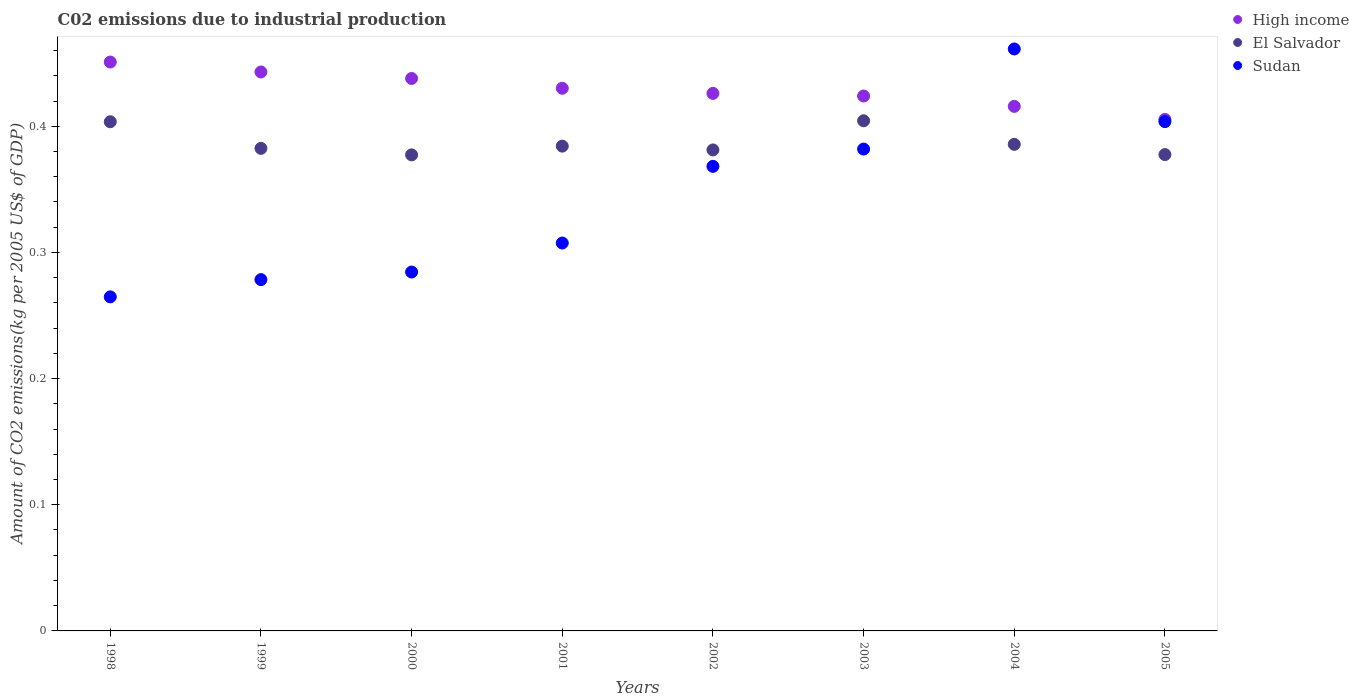Is the number of dotlines equal to the number of legend labels?
Provide a short and direct response. Yes. What is the amount of CO2 emitted due to industrial production in Sudan in 1999?
Give a very brief answer. 0.28. Across all years, what is the maximum amount of CO2 emitted due to industrial production in Sudan?
Offer a terse response. 0.46. Across all years, what is the minimum amount of CO2 emitted due to industrial production in Sudan?
Your answer should be compact. 0.26. What is the total amount of CO2 emitted due to industrial production in El Salvador in the graph?
Keep it short and to the point. 3.1. What is the difference between the amount of CO2 emitted due to industrial production in Sudan in 1998 and that in 2004?
Your answer should be very brief. -0.2. What is the difference between the amount of CO2 emitted due to industrial production in Sudan in 2004 and the amount of CO2 emitted due to industrial production in El Salvador in 2002?
Make the answer very short. 0.08. What is the average amount of CO2 emitted due to industrial production in High income per year?
Your response must be concise. 0.43. In the year 1998, what is the difference between the amount of CO2 emitted due to industrial production in El Salvador and amount of CO2 emitted due to industrial production in High income?
Your response must be concise. -0.05. In how many years, is the amount of CO2 emitted due to industrial production in High income greater than 0.1 kg?
Give a very brief answer. 8. What is the ratio of the amount of CO2 emitted due to industrial production in Sudan in 2003 to that in 2004?
Offer a terse response. 0.83. Is the difference between the amount of CO2 emitted due to industrial production in El Salvador in 2002 and 2003 greater than the difference between the amount of CO2 emitted due to industrial production in High income in 2002 and 2003?
Offer a terse response. No. What is the difference between the highest and the second highest amount of CO2 emitted due to industrial production in Sudan?
Your response must be concise. 0.06. What is the difference between the highest and the lowest amount of CO2 emitted due to industrial production in Sudan?
Your answer should be compact. 0.2. Is the sum of the amount of CO2 emitted due to industrial production in High income in 1998 and 2002 greater than the maximum amount of CO2 emitted due to industrial production in Sudan across all years?
Your response must be concise. Yes. Is it the case that in every year, the sum of the amount of CO2 emitted due to industrial production in High income and amount of CO2 emitted due to industrial production in Sudan  is greater than the amount of CO2 emitted due to industrial production in El Salvador?
Your answer should be very brief. Yes. Is the amount of CO2 emitted due to industrial production in El Salvador strictly greater than the amount of CO2 emitted due to industrial production in Sudan over the years?
Keep it short and to the point. No. Is the amount of CO2 emitted due to industrial production in High income strictly less than the amount of CO2 emitted due to industrial production in Sudan over the years?
Your answer should be compact. No. How many dotlines are there?
Provide a succinct answer. 3. Are the values on the major ticks of Y-axis written in scientific E-notation?
Give a very brief answer. No. Where does the legend appear in the graph?
Offer a terse response. Top right. How many legend labels are there?
Your answer should be compact. 3. What is the title of the graph?
Provide a succinct answer. C02 emissions due to industrial production. What is the label or title of the Y-axis?
Your answer should be very brief. Amount of CO2 emissions(kg per 2005 US$ of GDP). What is the Amount of CO2 emissions(kg per 2005 US$ of GDP) in High income in 1998?
Provide a succinct answer. 0.45. What is the Amount of CO2 emissions(kg per 2005 US$ of GDP) in El Salvador in 1998?
Provide a succinct answer. 0.4. What is the Amount of CO2 emissions(kg per 2005 US$ of GDP) in Sudan in 1998?
Ensure brevity in your answer.  0.26. What is the Amount of CO2 emissions(kg per 2005 US$ of GDP) in High income in 1999?
Offer a terse response. 0.44. What is the Amount of CO2 emissions(kg per 2005 US$ of GDP) in El Salvador in 1999?
Your answer should be compact. 0.38. What is the Amount of CO2 emissions(kg per 2005 US$ of GDP) of Sudan in 1999?
Give a very brief answer. 0.28. What is the Amount of CO2 emissions(kg per 2005 US$ of GDP) in High income in 2000?
Offer a terse response. 0.44. What is the Amount of CO2 emissions(kg per 2005 US$ of GDP) of El Salvador in 2000?
Offer a very short reply. 0.38. What is the Amount of CO2 emissions(kg per 2005 US$ of GDP) of Sudan in 2000?
Provide a succinct answer. 0.28. What is the Amount of CO2 emissions(kg per 2005 US$ of GDP) in High income in 2001?
Offer a terse response. 0.43. What is the Amount of CO2 emissions(kg per 2005 US$ of GDP) of El Salvador in 2001?
Provide a short and direct response. 0.38. What is the Amount of CO2 emissions(kg per 2005 US$ of GDP) in Sudan in 2001?
Give a very brief answer. 0.31. What is the Amount of CO2 emissions(kg per 2005 US$ of GDP) of High income in 2002?
Your response must be concise. 0.43. What is the Amount of CO2 emissions(kg per 2005 US$ of GDP) in El Salvador in 2002?
Make the answer very short. 0.38. What is the Amount of CO2 emissions(kg per 2005 US$ of GDP) of Sudan in 2002?
Provide a succinct answer. 0.37. What is the Amount of CO2 emissions(kg per 2005 US$ of GDP) in High income in 2003?
Make the answer very short. 0.42. What is the Amount of CO2 emissions(kg per 2005 US$ of GDP) in El Salvador in 2003?
Your response must be concise. 0.4. What is the Amount of CO2 emissions(kg per 2005 US$ of GDP) of Sudan in 2003?
Ensure brevity in your answer.  0.38. What is the Amount of CO2 emissions(kg per 2005 US$ of GDP) of High income in 2004?
Provide a succinct answer. 0.42. What is the Amount of CO2 emissions(kg per 2005 US$ of GDP) of El Salvador in 2004?
Provide a short and direct response. 0.39. What is the Amount of CO2 emissions(kg per 2005 US$ of GDP) of Sudan in 2004?
Provide a succinct answer. 0.46. What is the Amount of CO2 emissions(kg per 2005 US$ of GDP) of High income in 2005?
Your answer should be very brief. 0.41. What is the Amount of CO2 emissions(kg per 2005 US$ of GDP) in El Salvador in 2005?
Keep it short and to the point. 0.38. What is the Amount of CO2 emissions(kg per 2005 US$ of GDP) in Sudan in 2005?
Make the answer very short. 0.4. Across all years, what is the maximum Amount of CO2 emissions(kg per 2005 US$ of GDP) of High income?
Make the answer very short. 0.45. Across all years, what is the maximum Amount of CO2 emissions(kg per 2005 US$ of GDP) of El Salvador?
Offer a terse response. 0.4. Across all years, what is the maximum Amount of CO2 emissions(kg per 2005 US$ of GDP) in Sudan?
Provide a succinct answer. 0.46. Across all years, what is the minimum Amount of CO2 emissions(kg per 2005 US$ of GDP) in High income?
Ensure brevity in your answer.  0.41. Across all years, what is the minimum Amount of CO2 emissions(kg per 2005 US$ of GDP) of El Salvador?
Give a very brief answer. 0.38. Across all years, what is the minimum Amount of CO2 emissions(kg per 2005 US$ of GDP) in Sudan?
Give a very brief answer. 0.26. What is the total Amount of CO2 emissions(kg per 2005 US$ of GDP) of High income in the graph?
Your answer should be compact. 3.43. What is the total Amount of CO2 emissions(kg per 2005 US$ of GDP) of El Salvador in the graph?
Ensure brevity in your answer.  3.1. What is the total Amount of CO2 emissions(kg per 2005 US$ of GDP) of Sudan in the graph?
Provide a succinct answer. 2.75. What is the difference between the Amount of CO2 emissions(kg per 2005 US$ of GDP) of High income in 1998 and that in 1999?
Make the answer very short. 0.01. What is the difference between the Amount of CO2 emissions(kg per 2005 US$ of GDP) of El Salvador in 1998 and that in 1999?
Make the answer very short. 0.02. What is the difference between the Amount of CO2 emissions(kg per 2005 US$ of GDP) in Sudan in 1998 and that in 1999?
Offer a terse response. -0.01. What is the difference between the Amount of CO2 emissions(kg per 2005 US$ of GDP) in High income in 1998 and that in 2000?
Your response must be concise. 0.01. What is the difference between the Amount of CO2 emissions(kg per 2005 US$ of GDP) of El Salvador in 1998 and that in 2000?
Keep it short and to the point. 0.03. What is the difference between the Amount of CO2 emissions(kg per 2005 US$ of GDP) of Sudan in 1998 and that in 2000?
Offer a terse response. -0.02. What is the difference between the Amount of CO2 emissions(kg per 2005 US$ of GDP) of High income in 1998 and that in 2001?
Keep it short and to the point. 0.02. What is the difference between the Amount of CO2 emissions(kg per 2005 US$ of GDP) in El Salvador in 1998 and that in 2001?
Provide a succinct answer. 0.02. What is the difference between the Amount of CO2 emissions(kg per 2005 US$ of GDP) of Sudan in 1998 and that in 2001?
Give a very brief answer. -0.04. What is the difference between the Amount of CO2 emissions(kg per 2005 US$ of GDP) of High income in 1998 and that in 2002?
Make the answer very short. 0.02. What is the difference between the Amount of CO2 emissions(kg per 2005 US$ of GDP) in El Salvador in 1998 and that in 2002?
Your answer should be very brief. 0.02. What is the difference between the Amount of CO2 emissions(kg per 2005 US$ of GDP) in Sudan in 1998 and that in 2002?
Your response must be concise. -0.1. What is the difference between the Amount of CO2 emissions(kg per 2005 US$ of GDP) of High income in 1998 and that in 2003?
Provide a short and direct response. 0.03. What is the difference between the Amount of CO2 emissions(kg per 2005 US$ of GDP) in El Salvador in 1998 and that in 2003?
Keep it short and to the point. -0. What is the difference between the Amount of CO2 emissions(kg per 2005 US$ of GDP) in Sudan in 1998 and that in 2003?
Keep it short and to the point. -0.12. What is the difference between the Amount of CO2 emissions(kg per 2005 US$ of GDP) of High income in 1998 and that in 2004?
Provide a short and direct response. 0.04. What is the difference between the Amount of CO2 emissions(kg per 2005 US$ of GDP) of El Salvador in 1998 and that in 2004?
Offer a very short reply. 0.02. What is the difference between the Amount of CO2 emissions(kg per 2005 US$ of GDP) in Sudan in 1998 and that in 2004?
Provide a succinct answer. -0.2. What is the difference between the Amount of CO2 emissions(kg per 2005 US$ of GDP) of High income in 1998 and that in 2005?
Provide a short and direct response. 0.05. What is the difference between the Amount of CO2 emissions(kg per 2005 US$ of GDP) in El Salvador in 1998 and that in 2005?
Offer a very short reply. 0.03. What is the difference between the Amount of CO2 emissions(kg per 2005 US$ of GDP) in Sudan in 1998 and that in 2005?
Keep it short and to the point. -0.14. What is the difference between the Amount of CO2 emissions(kg per 2005 US$ of GDP) in High income in 1999 and that in 2000?
Ensure brevity in your answer.  0.01. What is the difference between the Amount of CO2 emissions(kg per 2005 US$ of GDP) in El Salvador in 1999 and that in 2000?
Make the answer very short. 0.01. What is the difference between the Amount of CO2 emissions(kg per 2005 US$ of GDP) of Sudan in 1999 and that in 2000?
Offer a very short reply. -0.01. What is the difference between the Amount of CO2 emissions(kg per 2005 US$ of GDP) of High income in 1999 and that in 2001?
Your response must be concise. 0.01. What is the difference between the Amount of CO2 emissions(kg per 2005 US$ of GDP) of El Salvador in 1999 and that in 2001?
Give a very brief answer. -0. What is the difference between the Amount of CO2 emissions(kg per 2005 US$ of GDP) in Sudan in 1999 and that in 2001?
Your answer should be compact. -0.03. What is the difference between the Amount of CO2 emissions(kg per 2005 US$ of GDP) of High income in 1999 and that in 2002?
Ensure brevity in your answer.  0.02. What is the difference between the Amount of CO2 emissions(kg per 2005 US$ of GDP) of El Salvador in 1999 and that in 2002?
Your response must be concise. 0. What is the difference between the Amount of CO2 emissions(kg per 2005 US$ of GDP) in Sudan in 1999 and that in 2002?
Make the answer very short. -0.09. What is the difference between the Amount of CO2 emissions(kg per 2005 US$ of GDP) of High income in 1999 and that in 2003?
Offer a very short reply. 0.02. What is the difference between the Amount of CO2 emissions(kg per 2005 US$ of GDP) in El Salvador in 1999 and that in 2003?
Make the answer very short. -0.02. What is the difference between the Amount of CO2 emissions(kg per 2005 US$ of GDP) of Sudan in 1999 and that in 2003?
Provide a succinct answer. -0.1. What is the difference between the Amount of CO2 emissions(kg per 2005 US$ of GDP) in High income in 1999 and that in 2004?
Ensure brevity in your answer.  0.03. What is the difference between the Amount of CO2 emissions(kg per 2005 US$ of GDP) in El Salvador in 1999 and that in 2004?
Your answer should be very brief. -0. What is the difference between the Amount of CO2 emissions(kg per 2005 US$ of GDP) of Sudan in 1999 and that in 2004?
Keep it short and to the point. -0.18. What is the difference between the Amount of CO2 emissions(kg per 2005 US$ of GDP) in High income in 1999 and that in 2005?
Keep it short and to the point. 0.04. What is the difference between the Amount of CO2 emissions(kg per 2005 US$ of GDP) of El Salvador in 1999 and that in 2005?
Provide a short and direct response. 0. What is the difference between the Amount of CO2 emissions(kg per 2005 US$ of GDP) in Sudan in 1999 and that in 2005?
Provide a succinct answer. -0.13. What is the difference between the Amount of CO2 emissions(kg per 2005 US$ of GDP) in High income in 2000 and that in 2001?
Provide a succinct answer. 0.01. What is the difference between the Amount of CO2 emissions(kg per 2005 US$ of GDP) in El Salvador in 2000 and that in 2001?
Offer a very short reply. -0.01. What is the difference between the Amount of CO2 emissions(kg per 2005 US$ of GDP) of Sudan in 2000 and that in 2001?
Give a very brief answer. -0.02. What is the difference between the Amount of CO2 emissions(kg per 2005 US$ of GDP) in High income in 2000 and that in 2002?
Your response must be concise. 0.01. What is the difference between the Amount of CO2 emissions(kg per 2005 US$ of GDP) in El Salvador in 2000 and that in 2002?
Ensure brevity in your answer.  -0. What is the difference between the Amount of CO2 emissions(kg per 2005 US$ of GDP) of Sudan in 2000 and that in 2002?
Give a very brief answer. -0.08. What is the difference between the Amount of CO2 emissions(kg per 2005 US$ of GDP) of High income in 2000 and that in 2003?
Keep it short and to the point. 0.01. What is the difference between the Amount of CO2 emissions(kg per 2005 US$ of GDP) in El Salvador in 2000 and that in 2003?
Give a very brief answer. -0.03. What is the difference between the Amount of CO2 emissions(kg per 2005 US$ of GDP) in Sudan in 2000 and that in 2003?
Keep it short and to the point. -0.1. What is the difference between the Amount of CO2 emissions(kg per 2005 US$ of GDP) of High income in 2000 and that in 2004?
Ensure brevity in your answer.  0.02. What is the difference between the Amount of CO2 emissions(kg per 2005 US$ of GDP) of El Salvador in 2000 and that in 2004?
Provide a short and direct response. -0.01. What is the difference between the Amount of CO2 emissions(kg per 2005 US$ of GDP) in Sudan in 2000 and that in 2004?
Your response must be concise. -0.18. What is the difference between the Amount of CO2 emissions(kg per 2005 US$ of GDP) in High income in 2000 and that in 2005?
Your answer should be compact. 0.03. What is the difference between the Amount of CO2 emissions(kg per 2005 US$ of GDP) in El Salvador in 2000 and that in 2005?
Ensure brevity in your answer.  -0. What is the difference between the Amount of CO2 emissions(kg per 2005 US$ of GDP) of Sudan in 2000 and that in 2005?
Ensure brevity in your answer.  -0.12. What is the difference between the Amount of CO2 emissions(kg per 2005 US$ of GDP) of High income in 2001 and that in 2002?
Give a very brief answer. 0. What is the difference between the Amount of CO2 emissions(kg per 2005 US$ of GDP) of El Salvador in 2001 and that in 2002?
Make the answer very short. 0. What is the difference between the Amount of CO2 emissions(kg per 2005 US$ of GDP) in Sudan in 2001 and that in 2002?
Offer a terse response. -0.06. What is the difference between the Amount of CO2 emissions(kg per 2005 US$ of GDP) of High income in 2001 and that in 2003?
Your response must be concise. 0.01. What is the difference between the Amount of CO2 emissions(kg per 2005 US$ of GDP) in El Salvador in 2001 and that in 2003?
Make the answer very short. -0.02. What is the difference between the Amount of CO2 emissions(kg per 2005 US$ of GDP) of Sudan in 2001 and that in 2003?
Offer a very short reply. -0.07. What is the difference between the Amount of CO2 emissions(kg per 2005 US$ of GDP) in High income in 2001 and that in 2004?
Provide a succinct answer. 0.01. What is the difference between the Amount of CO2 emissions(kg per 2005 US$ of GDP) of El Salvador in 2001 and that in 2004?
Provide a succinct answer. -0. What is the difference between the Amount of CO2 emissions(kg per 2005 US$ of GDP) in Sudan in 2001 and that in 2004?
Offer a terse response. -0.15. What is the difference between the Amount of CO2 emissions(kg per 2005 US$ of GDP) of High income in 2001 and that in 2005?
Your answer should be compact. 0.02. What is the difference between the Amount of CO2 emissions(kg per 2005 US$ of GDP) in El Salvador in 2001 and that in 2005?
Give a very brief answer. 0.01. What is the difference between the Amount of CO2 emissions(kg per 2005 US$ of GDP) of Sudan in 2001 and that in 2005?
Ensure brevity in your answer.  -0.1. What is the difference between the Amount of CO2 emissions(kg per 2005 US$ of GDP) in High income in 2002 and that in 2003?
Ensure brevity in your answer.  0. What is the difference between the Amount of CO2 emissions(kg per 2005 US$ of GDP) in El Salvador in 2002 and that in 2003?
Your response must be concise. -0.02. What is the difference between the Amount of CO2 emissions(kg per 2005 US$ of GDP) in Sudan in 2002 and that in 2003?
Provide a short and direct response. -0.01. What is the difference between the Amount of CO2 emissions(kg per 2005 US$ of GDP) of High income in 2002 and that in 2004?
Make the answer very short. 0.01. What is the difference between the Amount of CO2 emissions(kg per 2005 US$ of GDP) of El Salvador in 2002 and that in 2004?
Your answer should be compact. -0. What is the difference between the Amount of CO2 emissions(kg per 2005 US$ of GDP) of Sudan in 2002 and that in 2004?
Your answer should be compact. -0.09. What is the difference between the Amount of CO2 emissions(kg per 2005 US$ of GDP) of High income in 2002 and that in 2005?
Give a very brief answer. 0.02. What is the difference between the Amount of CO2 emissions(kg per 2005 US$ of GDP) of El Salvador in 2002 and that in 2005?
Your answer should be compact. 0. What is the difference between the Amount of CO2 emissions(kg per 2005 US$ of GDP) of Sudan in 2002 and that in 2005?
Your answer should be compact. -0.04. What is the difference between the Amount of CO2 emissions(kg per 2005 US$ of GDP) of High income in 2003 and that in 2004?
Your response must be concise. 0.01. What is the difference between the Amount of CO2 emissions(kg per 2005 US$ of GDP) of El Salvador in 2003 and that in 2004?
Provide a short and direct response. 0.02. What is the difference between the Amount of CO2 emissions(kg per 2005 US$ of GDP) in Sudan in 2003 and that in 2004?
Offer a very short reply. -0.08. What is the difference between the Amount of CO2 emissions(kg per 2005 US$ of GDP) in High income in 2003 and that in 2005?
Your answer should be compact. 0.02. What is the difference between the Amount of CO2 emissions(kg per 2005 US$ of GDP) of El Salvador in 2003 and that in 2005?
Provide a succinct answer. 0.03. What is the difference between the Amount of CO2 emissions(kg per 2005 US$ of GDP) of Sudan in 2003 and that in 2005?
Your response must be concise. -0.02. What is the difference between the Amount of CO2 emissions(kg per 2005 US$ of GDP) in High income in 2004 and that in 2005?
Keep it short and to the point. 0.01. What is the difference between the Amount of CO2 emissions(kg per 2005 US$ of GDP) in El Salvador in 2004 and that in 2005?
Offer a very short reply. 0.01. What is the difference between the Amount of CO2 emissions(kg per 2005 US$ of GDP) of Sudan in 2004 and that in 2005?
Your answer should be compact. 0.06. What is the difference between the Amount of CO2 emissions(kg per 2005 US$ of GDP) in High income in 1998 and the Amount of CO2 emissions(kg per 2005 US$ of GDP) in El Salvador in 1999?
Offer a terse response. 0.07. What is the difference between the Amount of CO2 emissions(kg per 2005 US$ of GDP) in High income in 1998 and the Amount of CO2 emissions(kg per 2005 US$ of GDP) in Sudan in 1999?
Offer a very short reply. 0.17. What is the difference between the Amount of CO2 emissions(kg per 2005 US$ of GDP) of El Salvador in 1998 and the Amount of CO2 emissions(kg per 2005 US$ of GDP) of Sudan in 1999?
Keep it short and to the point. 0.13. What is the difference between the Amount of CO2 emissions(kg per 2005 US$ of GDP) in High income in 1998 and the Amount of CO2 emissions(kg per 2005 US$ of GDP) in El Salvador in 2000?
Make the answer very short. 0.07. What is the difference between the Amount of CO2 emissions(kg per 2005 US$ of GDP) in High income in 1998 and the Amount of CO2 emissions(kg per 2005 US$ of GDP) in Sudan in 2000?
Keep it short and to the point. 0.17. What is the difference between the Amount of CO2 emissions(kg per 2005 US$ of GDP) in El Salvador in 1998 and the Amount of CO2 emissions(kg per 2005 US$ of GDP) in Sudan in 2000?
Make the answer very short. 0.12. What is the difference between the Amount of CO2 emissions(kg per 2005 US$ of GDP) of High income in 1998 and the Amount of CO2 emissions(kg per 2005 US$ of GDP) of El Salvador in 2001?
Make the answer very short. 0.07. What is the difference between the Amount of CO2 emissions(kg per 2005 US$ of GDP) of High income in 1998 and the Amount of CO2 emissions(kg per 2005 US$ of GDP) of Sudan in 2001?
Ensure brevity in your answer.  0.14. What is the difference between the Amount of CO2 emissions(kg per 2005 US$ of GDP) in El Salvador in 1998 and the Amount of CO2 emissions(kg per 2005 US$ of GDP) in Sudan in 2001?
Offer a terse response. 0.1. What is the difference between the Amount of CO2 emissions(kg per 2005 US$ of GDP) in High income in 1998 and the Amount of CO2 emissions(kg per 2005 US$ of GDP) in El Salvador in 2002?
Ensure brevity in your answer.  0.07. What is the difference between the Amount of CO2 emissions(kg per 2005 US$ of GDP) of High income in 1998 and the Amount of CO2 emissions(kg per 2005 US$ of GDP) of Sudan in 2002?
Provide a short and direct response. 0.08. What is the difference between the Amount of CO2 emissions(kg per 2005 US$ of GDP) of El Salvador in 1998 and the Amount of CO2 emissions(kg per 2005 US$ of GDP) of Sudan in 2002?
Provide a short and direct response. 0.04. What is the difference between the Amount of CO2 emissions(kg per 2005 US$ of GDP) in High income in 1998 and the Amount of CO2 emissions(kg per 2005 US$ of GDP) in El Salvador in 2003?
Give a very brief answer. 0.05. What is the difference between the Amount of CO2 emissions(kg per 2005 US$ of GDP) in High income in 1998 and the Amount of CO2 emissions(kg per 2005 US$ of GDP) in Sudan in 2003?
Your answer should be compact. 0.07. What is the difference between the Amount of CO2 emissions(kg per 2005 US$ of GDP) in El Salvador in 1998 and the Amount of CO2 emissions(kg per 2005 US$ of GDP) in Sudan in 2003?
Your response must be concise. 0.02. What is the difference between the Amount of CO2 emissions(kg per 2005 US$ of GDP) of High income in 1998 and the Amount of CO2 emissions(kg per 2005 US$ of GDP) of El Salvador in 2004?
Your answer should be compact. 0.07. What is the difference between the Amount of CO2 emissions(kg per 2005 US$ of GDP) in High income in 1998 and the Amount of CO2 emissions(kg per 2005 US$ of GDP) in Sudan in 2004?
Offer a very short reply. -0.01. What is the difference between the Amount of CO2 emissions(kg per 2005 US$ of GDP) of El Salvador in 1998 and the Amount of CO2 emissions(kg per 2005 US$ of GDP) of Sudan in 2004?
Offer a terse response. -0.06. What is the difference between the Amount of CO2 emissions(kg per 2005 US$ of GDP) in High income in 1998 and the Amount of CO2 emissions(kg per 2005 US$ of GDP) in El Salvador in 2005?
Your answer should be very brief. 0.07. What is the difference between the Amount of CO2 emissions(kg per 2005 US$ of GDP) of High income in 1998 and the Amount of CO2 emissions(kg per 2005 US$ of GDP) of Sudan in 2005?
Ensure brevity in your answer.  0.05. What is the difference between the Amount of CO2 emissions(kg per 2005 US$ of GDP) in El Salvador in 1998 and the Amount of CO2 emissions(kg per 2005 US$ of GDP) in Sudan in 2005?
Your answer should be very brief. -0. What is the difference between the Amount of CO2 emissions(kg per 2005 US$ of GDP) in High income in 1999 and the Amount of CO2 emissions(kg per 2005 US$ of GDP) in El Salvador in 2000?
Provide a short and direct response. 0.07. What is the difference between the Amount of CO2 emissions(kg per 2005 US$ of GDP) of High income in 1999 and the Amount of CO2 emissions(kg per 2005 US$ of GDP) of Sudan in 2000?
Offer a terse response. 0.16. What is the difference between the Amount of CO2 emissions(kg per 2005 US$ of GDP) of El Salvador in 1999 and the Amount of CO2 emissions(kg per 2005 US$ of GDP) of Sudan in 2000?
Your answer should be very brief. 0.1. What is the difference between the Amount of CO2 emissions(kg per 2005 US$ of GDP) of High income in 1999 and the Amount of CO2 emissions(kg per 2005 US$ of GDP) of El Salvador in 2001?
Your answer should be very brief. 0.06. What is the difference between the Amount of CO2 emissions(kg per 2005 US$ of GDP) in High income in 1999 and the Amount of CO2 emissions(kg per 2005 US$ of GDP) in Sudan in 2001?
Provide a short and direct response. 0.14. What is the difference between the Amount of CO2 emissions(kg per 2005 US$ of GDP) of El Salvador in 1999 and the Amount of CO2 emissions(kg per 2005 US$ of GDP) of Sudan in 2001?
Provide a short and direct response. 0.07. What is the difference between the Amount of CO2 emissions(kg per 2005 US$ of GDP) of High income in 1999 and the Amount of CO2 emissions(kg per 2005 US$ of GDP) of El Salvador in 2002?
Offer a very short reply. 0.06. What is the difference between the Amount of CO2 emissions(kg per 2005 US$ of GDP) of High income in 1999 and the Amount of CO2 emissions(kg per 2005 US$ of GDP) of Sudan in 2002?
Make the answer very short. 0.07. What is the difference between the Amount of CO2 emissions(kg per 2005 US$ of GDP) in El Salvador in 1999 and the Amount of CO2 emissions(kg per 2005 US$ of GDP) in Sudan in 2002?
Provide a succinct answer. 0.01. What is the difference between the Amount of CO2 emissions(kg per 2005 US$ of GDP) in High income in 1999 and the Amount of CO2 emissions(kg per 2005 US$ of GDP) in El Salvador in 2003?
Ensure brevity in your answer.  0.04. What is the difference between the Amount of CO2 emissions(kg per 2005 US$ of GDP) in High income in 1999 and the Amount of CO2 emissions(kg per 2005 US$ of GDP) in Sudan in 2003?
Your answer should be very brief. 0.06. What is the difference between the Amount of CO2 emissions(kg per 2005 US$ of GDP) in El Salvador in 1999 and the Amount of CO2 emissions(kg per 2005 US$ of GDP) in Sudan in 2003?
Provide a short and direct response. 0. What is the difference between the Amount of CO2 emissions(kg per 2005 US$ of GDP) in High income in 1999 and the Amount of CO2 emissions(kg per 2005 US$ of GDP) in El Salvador in 2004?
Keep it short and to the point. 0.06. What is the difference between the Amount of CO2 emissions(kg per 2005 US$ of GDP) in High income in 1999 and the Amount of CO2 emissions(kg per 2005 US$ of GDP) in Sudan in 2004?
Your answer should be very brief. -0.02. What is the difference between the Amount of CO2 emissions(kg per 2005 US$ of GDP) of El Salvador in 1999 and the Amount of CO2 emissions(kg per 2005 US$ of GDP) of Sudan in 2004?
Give a very brief answer. -0.08. What is the difference between the Amount of CO2 emissions(kg per 2005 US$ of GDP) in High income in 1999 and the Amount of CO2 emissions(kg per 2005 US$ of GDP) in El Salvador in 2005?
Provide a succinct answer. 0.07. What is the difference between the Amount of CO2 emissions(kg per 2005 US$ of GDP) of High income in 1999 and the Amount of CO2 emissions(kg per 2005 US$ of GDP) of Sudan in 2005?
Ensure brevity in your answer.  0.04. What is the difference between the Amount of CO2 emissions(kg per 2005 US$ of GDP) of El Salvador in 1999 and the Amount of CO2 emissions(kg per 2005 US$ of GDP) of Sudan in 2005?
Your answer should be very brief. -0.02. What is the difference between the Amount of CO2 emissions(kg per 2005 US$ of GDP) of High income in 2000 and the Amount of CO2 emissions(kg per 2005 US$ of GDP) of El Salvador in 2001?
Your answer should be very brief. 0.05. What is the difference between the Amount of CO2 emissions(kg per 2005 US$ of GDP) of High income in 2000 and the Amount of CO2 emissions(kg per 2005 US$ of GDP) of Sudan in 2001?
Make the answer very short. 0.13. What is the difference between the Amount of CO2 emissions(kg per 2005 US$ of GDP) in El Salvador in 2000 and the Amount of CO2 emissions(kg per 2005 US$ of GDP) in Sudan in 2001?
Offer a terse response. 0.07. What is the difference between the Amount of CO2 emissions(kg per 2005 US$ of GDP) in High income in 2000 and the Amount of CO2 emissions(kg per 2005 US$ of GDP) in El Salvador in 2002?
Provide a succinct answer. 0.06. What is the difference between the Amount of CO2 emissions(kg per 2005 US$ of GDP) in High income in 2000 and the Amount of CO2 emissions(kg per 2005 US$ of GDP) in Sudan in 2002?
Your answer should be very brief. 0.07. What is the difference between the Amount of CO2 emissions(kg per 2005 US$ of GDP) of El Salvador in 2000 and the Amount of CO2 emissions(kg per 2005 US$ of GDP) of Sudan in 2002?
Provide a short and direct response. 0.01. What is the difference between the Amount of CO2 emissions(kg per 2005 US$ of GDP) of High income in 2000 and the Amount of CO2 emissions(kg per 2005 US$ of GDP) of El Salvador in 2003?
Offer a terse response. 0.03. What is the difference between the Amount of CO2 emissions(kg per 2005 US$ of GDP) in High income in 2000 and the Amount of CO2 emissions(kg per 2005 US$ of GDP) in Sudan in 2003?
Keep it short and to the point. 0.06. What is the difference between the Amount of CO2 emissions(kg per 2005 US$ of GDP) in El Salvador in 2000 and the Amount of CO2 emissions(kg per 2005 US$ of GDP) in Sudan in 2003?
Offer a terse response. -0. What is the difference between the Amount of CO2 emissions(kg per 2005 US$ of GDP) of High income in 2000 and the Amount of CO2 emissions(kg per 2005 US$ of GDP) of El Salvador in 2004?
Keep it short and to the point. 0.05. What is the difference between the Amount of CO2 emissions(kg per 2005 US$ of GDP) of High income in 2000 and the Amount of CO2 emissions(kg per 2005 US$ of GDP) of Sudan in 2004?
Your response must be concise. -0.02. What is the difference between the Amount of CO2 emissions(kg per 2005 US$ of GDP) in El Salvador in 2000 and the Amount of CO2 emissions(kg per 2005 US$ of GDP) in Sudan in 2004?
Keep it short and to the point. -0.08. What is the difference between the Amount of CO2 emissions(kg per 2005 US$ of GDP) in High income in 2000 and the Amount of CO2 emissions(kg per 2005 US$ of GDP) in El Salvador in 2005?
Ensure brevity in your answer.  0.06. What is the difference between the Amount of CO2 emissions(kg per 2005 US$ of GDP) in High income in 2000 and the Amount of CO2 emissions(kg per 2005 US$ of GDP) in Sudan in 2005?
Give a very brief answer. 0.03. What is the difference between the Amount of CO2 emissions(kg per 2005 US$ of GDP) of El Salvador in 2000 and the Amount of CO2 emissions(kg per 2005 US$ of GDP) of Sudan in 2005?
Ensure brevity in your answer.  -0.03. What is the difference between the Amount of CO2 emissions(kg per 2005 US$ of GDP) in High income in 2001 and the Amount of CO2 emissions(kg per 2005 US$ of GDP) in El Salvador in 2002?
Offer a very short reply. 0.05. What is the difference between the Amount of CO2 emissions(kg per 2005 US$ of GDP) in High income in 2001 and the Amount of CO2 emissions(kg per 2005 US$ of GDP) in Sudan in 2002?
Your answer should be compact. 0.06. What is the difference between the Amount of CO2 emissions(kg per 2005 US$ of GDP) of El Salvador in 2001 and the Amount of CO2 emissions(kg per 2005 US$ of GDP) of Sudan in 2002?
Give a very brief answer. 0.02. What is the difference between the Amount of CO2 emissions(kg per 2005 US$ of GDP) in High income in 2001 and the Amount of CO2 emissions(kg per 2005 US$ of GDP) in El Salvador in 2003?
Provide a succinct answer. 0.03. What is the difference between the Amount of CO2 emissions(kg per 2005 US$ of GDP) in High income in 2001 and the Amount of CO2 emissions(kg per 2005 US$ of GDP) in Sudan in 2003?
Your answer should be compact. 0.05. What is the difference between the Amount of CO2 emissions(kg per 2005 US$ of GDP) in El Salvador in 2001 and the Amount of CO2 emissions(kg per 2005 US$ of GDP) in Sudan in 2003?
Provide a succinct answer. 0. What is the difference between the Amount of CO2 emissions(kg per 2005 US$ of GDP) of High income in 2001 and the Amount of CO2 emissions(kg per 2005 US$ of GDP) of El Salvador in 2004?
Make the answer very short. 0.04. What is the difference between the Amount of CO2 emissions(kg per 2005 US$ of GDP) in High income in 2001 and the Amount of CO2 emissions(kg per 2005 US$ of GDP) in Sudan in 2004?
Offer a terse response. -0.03. What is the difference between the Amount of CO2 emissions(kg per 2005 US$ of GDP) of El Salvador in 2001 and the Amount of CO2 emissions(kg per 2005 US$ of GDP) of Sudan in 2004?
Provide a short and direct response. -0.08. What is the difference between the Amount of CO2 emissions(kg per 2005 US$ of GDP) in High income in 2001 and the Amount of CO2 emissions(kg per 2005 US$ of GDP) in El Salvador in 2005?
Your answer should be very brief. 0.05. What is the difference between the Amount of CO2 emissions(kg per 2005 US$ of GDP) of High income in 2001 and the Amount of CO2 emissions(kg per 2005 US$ of GDP) of Sudan in 2005?
Provide a short and direct response. 0.03. What is the difference between the Amount of CO2 emissions(kg per 2005 US$ of GDP) of El Salvador in 2001 and the Amount of CO2 emissions(kg per 2005 US$ of GDP) of Sudan in 2005?
Ensure brevity in your answer.  -0.02. What is the difference between the Amount of CO2 emissions(kg per 2005 US$ of GDP) of High income in 2002 and the Amount of CO2 emissions(kg per 2005 US$ of GDP) of El Salvador in 2003?
Give a very brief answer. 0.02. What is the difference between the Amount of CO2 emissions(kg per 2005 US$ of GDP) in High income in 2002 and the Amount of CO2 emissions(kg per 2005 US$ of GDP) in Sudan in 2003?
Make the answer very short. 0.04. What is the difference between the Amount of CO2 emissions(kg per 2005 US$ of GDP) in El Salvador in 2002 and the Amount of CO2 emissions(kg per 2005 US$ of GDP) in Sudan in 2003?
Keep it short and to the point. -0. What is the difference between the Amount of CO2 emissions(kg per 2005 US$ of GDP) in High income in 2002 and the Amount of CO2 emissions(kg per 2005 US$ of GDP) in El Salvador in 2004?
Ensure brevity in your answer.  0.04. What is the difference between the Amount of CO2 emissions(kg per 2005 US$ of GDP) of High income in 2002 and the Amount of CO2 emissions(kg per 2005 US$ of GDP) of Sudan in 2004?
Make the answer very short. -0.04. What is the difference between the Amount of CO2 emissions(kg per 2005 US$ of GDP) of El Salvador in 2002 and the Amount of CO2 emissions(kg per 2005 US$ of GDP) of Sudan in 2004?
Make the answer very short. -0.08. What is the difference between the Amount of CO2 emissions(kg per 2005 US$ of GDP) of High income in 2002 and the Amount of CO2 emissions(kg per 2005 US$ of GDP) of El Salvador in 2005?
Keep it short and to the point. 0.05. What is the difference between the Amount of CO2 emissions(kg per 2005 US$ of GDP) of High income in 2002 and the Amount of CO2 emissions(kg per 2005 US$ of GDP) of Sudan in 2005?
Your answer should be compact. 0.02. What is the difference between the Amount of CO2 emissions(kg per 2005 US$ of GDP) of El Salvador in 2002 and the Amount of CO2 emissions(kg per 2005 US$ of GDP) of Sudan in 2005?
Provide a short and direct response. -0.02. What is the difference between the Amount of CO2 emissions(kg per 2005 US$ of GDP) in High income in 2003 and the Amount of CO2 emissions(kg per 2005 US$ of GDP) in El Salvador in 2004?
Your answer should be very brief. 0.04. What is the difference between the Amount of CO2 emissions(kg per 2005 US$ of GDP) of High income in 2003 and the Amount of CO2 emissions(kg per 2005 US$ of GDP) of Sudan in 2004?
Provide a succinct answer. -0.04. What is the difference between the Amount of CO2 emissions(kg per 2005 US$ of GDP) in El Salvador in 2003 and the Amount of CO2 emissions(kg per 2005 US$ of GDP) in Sudan in 2004?
Give a very brief answer. -0.06. What is the difference between the Amount of CO2 emissions(kg per 2005 US$ of GDP) of High income in 2003 and the Amount of CO2 emissions(kg per 2005 US$ of GDP) of El Salvador in 2005?
Offer a terse response. 0.05. What is the difference between the Amount of CO2 emissions(kg per 2005 US$ of GDP) of High income in 2003 and the Amount of CO2 emissions(kg per 2005 US$ of GDP) of Sudan in 2005?
Your answer should be compact. 0.02. What is the difference between the Amount of CO2 emissions(kg per 2005 US$ of GDP) of El Salvador in 2003 and the Amount of CO2 emissions(kg per 2005 US$ of GDP) of Sudan in 2005?
Your answer should be compact. 0. What is the difference between the Amount of CO2 emissions(kg per 2005 US$ of GDP) of High income in 2004 and the Amount of CO2 emissions(kg per 2005 US$ of GDP) of El Salvador in 2005?
Keep it short and to the point. 0.04. What is the difference between the Amount of CO2 emissions(kg per 2005 US$ of GDP) of High income in 2004 and the Amount of CO2 emissions(kg per 2005 US$ of GDP) of Sudan in 2005?
Give a very brief answer. 0.01. What is the difference between the Amount of CO2 emissions(kg per 2005 US$ of GDP) of El Salvador in 2004 and the Amount of CO2 emissions(kg per 2005 US$ of GDP) of Sudan in 2005?
Your response must be concise. -0.02. What is the average Amount of CO2 emissions(kg per 2005 US$ of GDP) in High income per year?
Offer a terse response. 0.43. What is the average Amount of CO2 emissions(kg per 2005 US$ of GDP) in El Salvador per year?
Offer a very short reply. 0.39. What is the average Amount of CO2 emissions(kg per 2005 US$ of GDP) in Sudan per year?
Offer a very short reply. 0.34. In the year 1998, what is the difference between the Amount of CO2 emissions(kg per 2005 US$ of GDP) of High income and Amount of CO2 emissions(kg per 2005 US$ of GDP) of El Salvador?
Give a very brief answer. 0.05. In the year 1998, what is the difference between the Amount of CO2 emissions(kg per 2005 US$ of GDP) of High income and Amount of CO2 emissions(kg per 2005 US$ of GDP) of Sudan?
Your response must be concise. 0.19. In the year 1998, what is the difference between the Amount of CO2 emissions(kg per 2005 US$ of GDP) in El Salvador and Amount of CO2 emissions(kg per 2005 US$ of GDP) in Sudan?
Make the answer very short. 0.14. In the year 1999, what is the difference between the Amount of CO2 emissions(kg per 2005 US$ of GDP) in High income and Amount of CO2 emissions(kg per 2005 US$ of GDP) in El Salvador?
Provide a succinct answer. 0.06. In the year 1999, what is the difference between the Amount of CO2 emissions(kg per 2005 US$ of GDP) in High income and Amount of CO2 emissions(kg per 2005 US$ of GDP) in Sudan?
Ensure brevity in your answer.  0.16. In the year 1999, what is the difference between the Amount of CO2 emissions(kg per 2005 US$ of GDP) in El Salvador and Amount of CO2 emissions(kg per 2005 US$ of GDP) in Sudan?
Make the answer very short. 0.1. In the year 2000, what is the difference between the Amount of CO2 emissions(kg per 2005 US$ of GDP) of High income and Amount of CO2 emissions(kg per 2005 US$ of GDP) of El Salvador?
Give a very brief answer. 0.06. In the year 2000, what is the difference between the Amount of CO2 emissions(kg per 2005 US$ of GDP) of High income and Amount of CO2 emissions(kg per 2005 US$ of GDP) of Sudan?
Make the answer very short. 0.15. In the year 2000, what is the difference between the Amount of CO2 emissions(kg per 2005 US$ of GDP) in El Salvador and Amount of CO2 emissions(kg per 2005 US$ of GDP) in Sudan?
Make the answer very short. 0.09. In the year 2001, what is the difference between the Amount of CO2 emissions(kg per 2005 US$ of GDP) in High income and Amount of CO2 emissions(kg per 2005 US$ of GDP) in El Salvador?
Give a very brief answer. 0.05. In the year 2001, what is the difference between the Amount of CO2 emissions(kg per 2005 US$ of GDP) in High income and Amount of CO2 emissions(kg per 2005 US$ of GDP) in Sudan?
Provide a short and direct response. 0.12. In the year 2001, what is the difference between the Amount of CO2 emissions(kg per 2005 US$ of GDP) of El Salvador and Amount of CO2 emissions(kg per 2005 US$ of GDP) of Sudan?
Provide a short and direct response. 0.08. In the year 2002, what is the difference between the Amount of CO2 emissions(kg per 2005 US$ of GDP) of High income and Amount of CO2 emissions(kg per 2005 US$ of GDP) of El Salvador?
Make the answer very short. 0.04. In the year 2002, what is the difference between the Amount of CO2 emissions(kg per 2005 US$ of GDP) of High income and Amount of CO2 emissions(kg per 2005 US$ of GDP) of Sudan?
Offer a very short reply. 0.06. In the year 2002, what is the difference between the Amount of CO2 emissions(kg per 2005 US$ of GDP) of El Salvador and Amount of CO2 emissions(kg per 2005 US$ of GDP) of Sudan?
Offer a very short reply. 0.01. In the year 2003, what is the difference between the Amount of CO2 emissions(kg per 2005 US$ of GDP) of High income and Amount of CO2 emissions(kg per 2005 US$ of GDP) of El Salvador?
Your answer should be very brief. 0.02. In the year 2003, what is the difference between the Amount of CO2 emissions(kg per 2005 US$ of GDP) of High income and Amount of CO2 emissions(kg per 2005 US$ of GDP) of Sudan?
Provide a short and direct response. 0.04. In the year 2003, what is the difference between the Amount of CO2 emissions(kg per 2005 US$ of GDP) in El Salvador and Amount of CO2 emissions(kg per 2005 US$ of GDP) in Sudan?
Offer a terse response. 0.02. In the year 2004, what is the difference between the Amount of CO2 emissions(kg per 2005 US$ of GDP) in High income and Amount of CO2 emissions(kg per 2005 US$ of GDP) in El Salvador?
Make the answer very short. 0.03. In the year 2004, what is the difference between the Amount of CO2 emissions(kg per 2005 US$ of GDP) of High income and Amount of CO2 emissions(kg per 2005 US$ of GDP) of Sudan?
Offer a very short reply. -0.05. In the year 2004, what is the difference between the Amount of CO2 emissions(kg per 2005 US$ of GDP) in El Salvador and Amount of CO2 emissions(kg per 2005 US$ of GDP) in Sudan?
Give a very brief answer. -0.08. In the year 2005, what is the difference between the Amount of CO2 emissions(kg per 2005 US$ of GDP) in High income and Amount of CO2 emissions(kg per 2005 US$ of GDP) in El Salvador?
Provide a succinct answer. 0.03. In the year 2005, what is the difference between the Amount of CO2 emissions(kg per 2005 US$ of GDP) of High income and Amount of CO2 emissions(kg per 2005 US$ of GDP) of Sudan?
Provide a succinct answer. 0. In the year 2005, what is the difference between the Amount of CO2 emissions(kg per 2005 US$ of GDP) in El Salvador and Amount of CO2 emissions(kg per 2005 US$ of GDP) in Sudan?
Your answer should be compact. -0.03. What is the ratio of the Amount of CO2 emissions(kg per 2005 US$ of GDP) of High income in 1998 to that in 1999?
Offer a very short reply. 1.02. What is the ratio of the Amount of CO2 emissions(kg per 2005 US$ of GDP) of El Salvador in 1998 to that in 1999?
Provide a succinct answer. 1.06. What is the ratio of the Amount of CO2 emissions(kg per 2005 US$ of GDP) in Sudan in 1998 to that in 1999?
Your answer should be very brief. 0.95. What is the ratio of the Amount of CO2 emissions(kg per 2005 US$ of GDP) in High income in 1998 to that in 2000?
Give a very brief answer. 1.03. What is the ratio of the Amount of CO2 emissions(kg per 2005 US$ of GDP) in El Salvador in 1998 to that in 2000?
Offer a terse response. 1.07. What is the ratio of the Amount of CO2 emissions(kg per 2005 US$ of GDP) of Sudan in 1998 to that in 2000?
Provide a succinct answer. 0.93. What is the ratio of the Amount of CO2 emissions(kg per 2005 US$ of GDP) of High income in 1998 to that in 2001?
Provide a succinct answer. 1.05. What is the ratio of the Amount of CO2 emissions(kg per 2005 US$ of GDP) in El Salvador in 1998 to that in 2001?
Keep it short and to the point. 1.05. What is the ratio of the Amount of CO2 emissions(kg per 2005 US$ of GDP) in Sudan in 1998 to that in 2001?
Provide a succinct answer. 0.86. What is the ratio of the Amount of CO2 emissions(kg per 2005 US$ of GDP) in High income in 1998 to that in 2002?
Make the answer very short. 1.06. What is the ratio of the Amount of CO2 emissions(kg per 2005 US$ of GDP) of El Salvador in 1998 to that in 2002?
Make the answer very short. 1.06. What is the ratio of the Amount of CO2 emissions(kg per 2005 US$ of GDP) of Sudan in 1998 to that in 2002?
Keep it short and to the point. 0.72. What is the ratio of the Amount of CO2 emissions(kg per 2005 US$ of GDP) of High income in 1998 to that in 2003?
Your answer should be compact. 1.06. What is the ratio of the Amount of CO2 emissions(kg per 2005 US$ of GDP) of Sudan in 1998 to that in 2003?
Offer a terse response. 0.69. What is the ratio of the Amount of CO2 emissions(kg per 2005 US$ of GDP) in High income in 1998 to that in 2004?
Keep it short and to the point. 1.08. What is the ratio of the Amount of CO2 emissions(kg per 2005 US$ of GDP) in El Salvador in 1998 to that in 2004?
Keep it short and to the point. 1.05. What is the ratio of the Amount of CO2 emissions(kg per 2005 US$ of GDP) in Sudan in 1998 to that in 2004?
Ensure brevity in your answer.  0.57. What is the ratio of the Amount of CO2 emissions(kg per 2005 US$ of GDP) in High income in 1998 to that in 2005?
Give a very brief answer. 1.11. What is the ratio of the Amount of CO2 emissions(kg per 2005 US$ of GDP) of El Salvador in 1998 to that in 2005?
Your answer should be very brief. 1.07. What is the ratio of the Amount of CO2 emissions(kg per 2005 US$ of GDP) in Sudan in 1998 to that in 2005?
Ensure brevity in your answer.  0.66. What is the ratio of the Amount of CO2 emissions(kg per 2005 US$ of GDP) of High income in 1999 to that in 2000?
Provide a short and direct response. 1.01. What is the ratio of the Amount of CO2 emissions(kg per 2005 US$ of GDP) of El Salvador in 1999 to that in 2000?
Your answer should be very brief. 1.01. What is the ratio of the Amount of CO2 emissions(kg per 2005 US$ of GDP) in Sudan in 1999 to that in 2000?
Your response must be concise. 0.98. What is the ratio of the Amount of CO2 emissions(kg per 2005 US$ of GDP) in High income in 1999 to that in 2001?
Keep it short and to the point. 1.03. What is the ratio of the Amount of CO2 emissions(kg per 2005 US$ of GDP) of Sudan in 1999 to that in 2001?
Your answer should be very brief. 0.91. What is the ratio of the Amount of CO2 emissions(kg per 2005 US$ of GDP) of High income in 1999 to that in 2002?
Provide a short and direct response. 1.04. What is the ratio of the Amount of CO2 emissions(kg per 2005 US$ of GDP) of Sudan in 1999 to that in 2002?
Your response must be concise. 0.76. What is the ratio of the Amount of CO2 emissions(kg per 2005 US$ of GDP) in High income in 1999 to that in 2003?
Ensure brevity in your answer.  1.04. What is the ratio of the Amount of CO2 emissions(kg per 2005 US$ of GDP) of El Salvador in 1999 to that in 2003?
Your answer should be compact. 0.95. What is the ratio of the Amount of CO2 emissions(kg per 2005 US$ of GDP) in Sudan in 1999 to that in 2003?
Make the answer very short. 0.73. What is the ratio of the Amount of CO2 emissions(kg per 2005 US$ of GDP) of High income in 1999 to that in 2004?
Make the answer very short. 1.07. What is the ratio of the Amount of CO2 emissions(kg per 2005 US$ of GDP) of Sudan in 1999 to that in 2004?
Your answer should be compact. 0.6. What is the ratio of the Amount of CO2 emissions(kg per 2005 US$ of GDP) of High income in 1999 to that in 2005?
Offer a very short reply. 1.09. What is the ratio of the Amount of CO2 emissions(kg per 2005 US$ of GDP) of El Salvador in 1999 to that in 2005?
Give a very brief answer. 1.01. What is the ratio of the Amount of CO2 emissions(kg per 2005 US$ of GDP) of Sudan in 1999 to that in 2005?
Make the answer very short. 0.69. What is the ratio of the Amount of CO2 emissions(kg per 2005 US$ of GDP) in High income in 2000 to that in 2001?
Provide a short and direct response. 1.02. What is the ratio of the Amount of CO2 emissions(kg per 2005 US$ of GDP) in Sudan in 2000 to that in 2001?
Provide a short and direct response. 0.93. What is the ratio of the Amount of CO2 emissions(kg per 2005 US$ of GDP) of High income in 2000 to that in 2002?
Give a very brief answer. 1.03. What is the ratio of the Amount of CO2 emissions(kg per 2005 US$ of GDP) of El Salvador in 2000 to that in 2002?
Provide a short and direct response. 0.99. What is the ratio of the Amount of CO2 emissions(kg per 2005 US$ of GDP) in Sudan in 2000 to that in 2002?
Ensure brevity in your answer.  0.77. What is the ratio of the Amount of CO2 emissions(kg per 2005 US$ of GDP) of High income in 2000 to that in 2003?
Ensure brevity in your answer.  1.03. What is the ratio of the Amount of CO2 emissions(kg per 2005 US$ of GDP) in El Salvador in 2000 to that in 2003?
Offer a terse response. 0.93. What is the ratio of the Amount of CO2 emissions(kg per 2005 US$ of GDP) of Sudan in 2000 to that in 2003?
Give a very brief answer. 0.74. What is the ratio of the Amount of CO2 emissions(kg per 2005 US$ of GDP) of High income in 2000 to that in 2004?
Your response must be concise. 1.05. What is the ratio of the Amount of CO2 emissions(kg per 2005 US$ of GDP) of El Salvador in 2000 to that in 2004?
Your answer should be very brief. 0.98. What is the ratio of the Amount of CO2 emissions(kg per 2005 US$ of GDP) of Sudan in 2000 to that in 2004?
Provide a short and direct response. 0.62. What is the ratio of the Amount of CO2 emissions(kg per 2005 US$ of GDP) in High income in 2000 to that in 2005?
Offer a very short reply. 1.08. What is the ratio of the Amount of CO2 emissions(kg per 2005 US$ of GDP) of El Salvador in 2000 to that in 2005?
Give a very brief answer. 1. What is the ratio of the Amount of CO2 emissions(kg per 2005 US$ of GDP) in Sudan in 2000 to that in 2005?
Provide a short and direct response. 0.7. What is the ratio of the Amount of CO2 emissions(kg per 2005 US$ of GDP) in High income in 2001 to that in 2002?
Your answer should be very brief. 1.01. What is the ratio of the Amount of CO2 emissions(kg per 2005 US$ of GDP) in El Salvador in 2001 to that in 2002?
Ensure brevity in your answer.  1.01. What is the ratio of the Amount of CO2 emissions(kg per 2005 US$ of GDP) in Sudan in 2001 to that in 2002?
Keep it short and to the point. 0.83. What is the ratio of the Amount of CO2 emissions(kg per 2005 US$ of GDP) in High income in 2001 to that in 2003?
Offer a terse response. 1.01. What is the ratio of the Amount of CO2 emissions(kg per 2005 US$ of GDP) in El Salvador in 2001 to that in 2003?
Ensure brevity in your answer.  0.95. What is the ratio of the Amount of CO2 emissions(kg per 2005 US$ of GDP) in Sudan in 2001 to that in 2003?
Your answer should be very brief. 0.81. What is the ratio of the Amount of CO2 emissions(kg per 2005 US$ of GDP) of High income in 2001 to that in 2004?
Offer a very short reply. 1.03. What is the ratio of the Amount of CO2 emissions(kg per 2005 US$ of GDP) of El Salvador in 2001 to that in 2004?
Make the answer very short. 1. What is the ratio of the Amount of CO2 emissions(kg per 2005 US$ of GDP) in Sudan in 2001 to that in 2004?
Offer a terse response. 0.67. What is the ratio of the Amount of CO2 emissions(kg per 2005 US$ of GDP) in High income in 2001 to that in 2005?
Provide a succinct answer. 1.06. What is the ratio of the Amount of CO2 emissions(kg per 2005 US$ of GDP) of El Salvador in 2001 to that in 2005?
Provide a succinct answer. 1.02. What is the ratio of the Amount of CO2 emissions(kg per 2005 US$ of GDP) of Sudan in 2001 to that in 2005?
Your answer should be very brief. 0.76. What is the ratio of the Amount of CO2 emissions(kg per 2005 US$ of GDP) of El Salvador in 2002 to that in 2003?
Ensure brevity in your answer.  0.94. What is the ratio of the Amount of CO2 emissions(kg per 2005 US$ of GDP) of Sudan in 2002 to that in 2003?
Provide a succinct answer. 0.96. What is the ratio of the Amount of CO2 emissions(kg per 2005 US$ of GDP) of High income in 2002 to that in 2004?
Your response must be concise. 1.02. What is the ratio of the Amount of CO2 emissions(kg per 2005 US$ of GDP) in Sudan in 2002 to that in 2004?
Make the answer very short. 0.8. What is the ratio of the Amount of CO2 emissions(kg per 2005 US$ of GDP) in High income in 2002 to that in 2005?
Your answer should be very brief. 1.05. What is the ratio of the Amount of CO2 emissions(kg per 2005 US$ of GDP) of El Salvador in 2002 to that in 2005?
Your response must be concise. 1.01. What is the ratio of the Amount of CO2 emissions(kg per 2005 US$ of GDP) of Sudan in 2002 to that in 2005?
Your answer should be very brief. 0.91. What is the ratio of the Amount of CO2 emissions(kg per 2005 US$ of GDP) of High income in 2003 to that in 2004?
Your answer should be very brief. 1.02. What is the ratio of the Amount of CO2 emissions(kg per 2005 US$ of GDP) in El Salvador in 2003 to that in 2004?
Offer a terse response. 1.05. What is the ratio of the Amount of CO2 emissions(kg per 2005 US$ of GDP) of Sudan in 2003 to that in 2004?
Offer a terse response. 0.83. What is the ratio of the Amount of CO2 emissions(kg per 2005 US$ of GDP) of High income in 2003 to that in 2005?
Offer a terse response. 1.05. What is the ratio of the Amount of CO2 emissions(kg per 2005 US$ of GDP) in El Salvador in 2003 to that in 2005?
Offer a very short reply. 1.07. What is the ratio of the Amount of CO2 emissions(kg per 2005 US$ of GDP) of Sudan in 2003 to that in 2005?
Offer a terse response. 0.95. What is the ratio of the Amount of CO2 emissions(kg per 2005 US$ of GDP) in High income in 2004 to that in 2005?
Offer a very short reply. 1.03. What is the ratio of the Amount of CO2 emissions(kg per 2005 US$ of GDP) in El Salvador in 2004 to that in 2005?
Make the answer very short. 1.02. What is the ratio of the Amount of CO2 emissions(kg per 2005 US$ of GDP) of Sudan in 2004 to that in 2005?
Your answer should be compact. 1.14. What is the difference between the highest and the second highest Amount of CO2 emissions(kg per 2005 US$ of GDP) in High income?
Give a very brief answer. 0.01. What is the difference between the highest and the second highest Amount of CO2 emissions(kg per 2005 US$ of GDP) of El Salvador?
Your response must be concise. 0. What is the difference between the highest and the second highest Amount of CO2 emissions(kg per 2005 US$ of GDP) in Sudan?
Offer a terse response. 0.06. What is the difference between the highest and the lowest Amount of CO2 emissions(kg per 2005 US$ of GDP) of High income?
Keep it short and to the point. 0.05. What is the difference between the highest and the lowest Amount of CO2 emissions(kg per 2005 US$ of GDP) of El Salvador?
Your answer should be compact. 0.03. What is the difference between the highest and the lowest Amount of CO2 emissions(kg per 2005 US$ of GDP) of Sudan?
Provide a short and direct response. 0.2. 